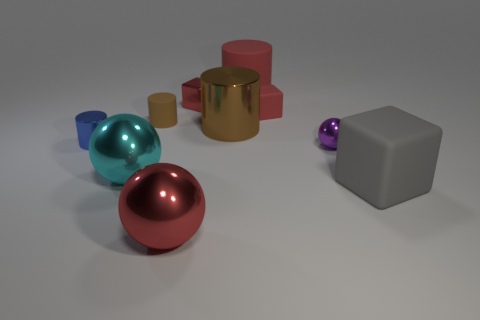Are there an equal number of blue cylinders on the right side of the large brown cylinder and small blue metallic things?
Ensure brevity in your answer.  No. What number of spheres are left of the rubber cube on the left side of the tiny metallic thing to the right of the red rubber block?
Keep it short and to the point. 2. What is the color of the tiny block that is in front of the tiny red metal cube?
Give a very brief answer. Red. There is a big object that is in front of the small red matte block and behind the tiny purple sphere; what material is it?
Provide a succinct answer. Metal. There is a large cylinder that is on the left side of the large red rubber cylinder; how many brown cylinders are left of it?
Your answer should be compact. 1. What shape is the blue shiny thing?
Keep it short and to the point. Cylinder. There is a purple thing that is the same material as the large red ball; what shape is it?
Your answer should be compact. Sphere. There is a brown object to the left of the red metal cube; does it have the same shape as the large brown thing?
Your answer should be very brief. Yes. The small red object that is right of the tiny shiny block has what shape?
Your response must be concise. Cube. What is the shape of the tiny thing that is the same color as the tiny metallic block?
Your answer should be very brief. Cube. 